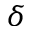Convert formula to latex. <formula><loc_0><loc_0><loc_500><loc_500>\delta</formula> 